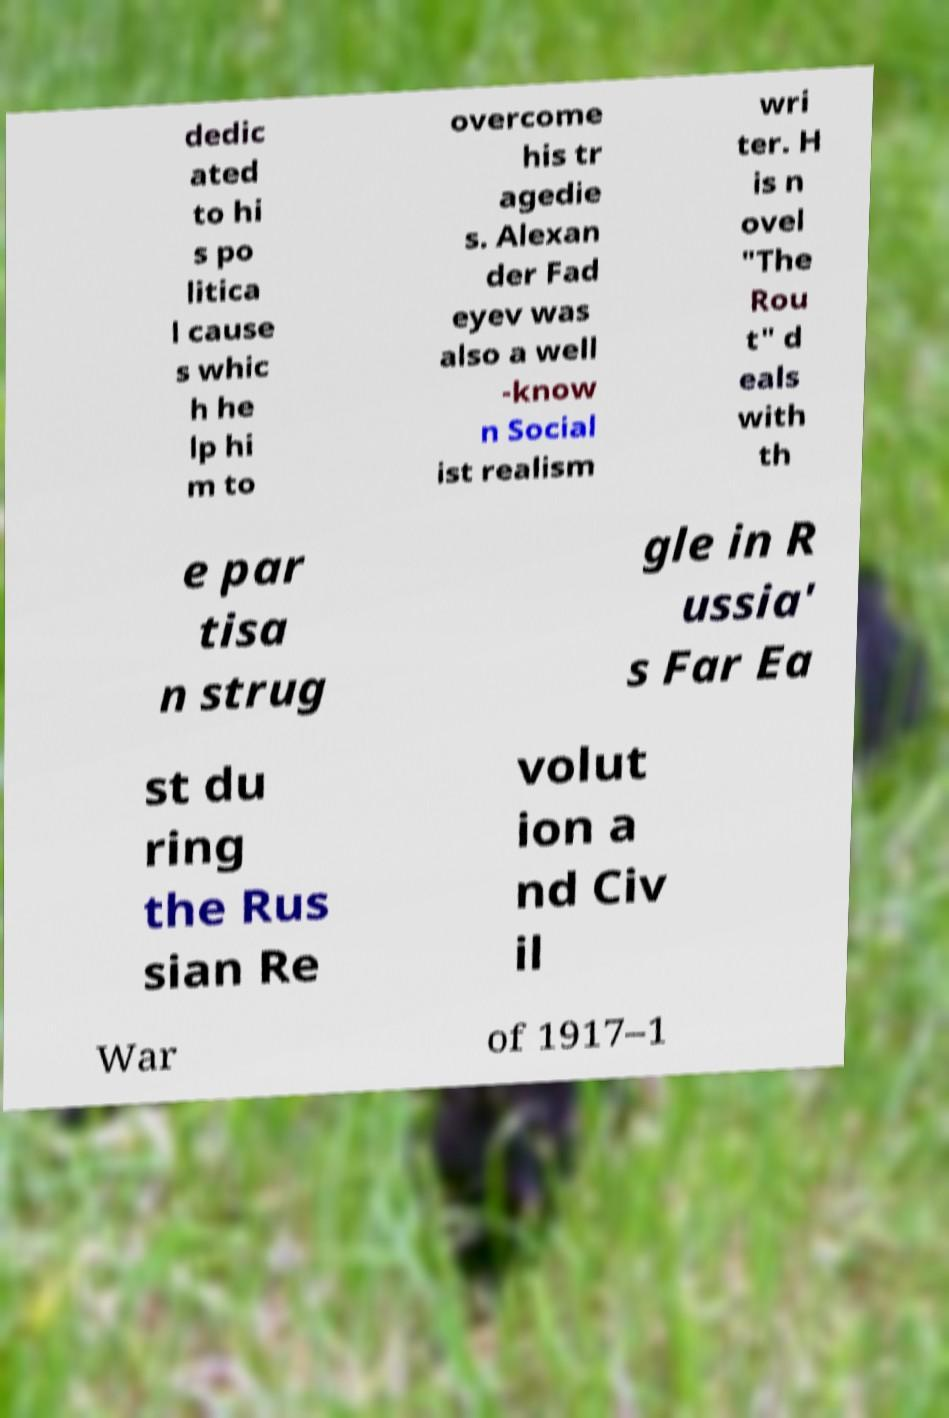Could you assist in decoding the text presented in this image and type it out clearly? dedic ated to hi s po litica l cause s whic h he lp hi m to overcome his tr agedie s. Alexan der Fad eyev was also a well -know n Social ist realism wri ter. H is n ovel "The Rou t" d eals with th e par tisa n strug gle in R ussia' s Far Ea st du ring the Rus sian Re volut ion a nd Civ il War of 1917–1 